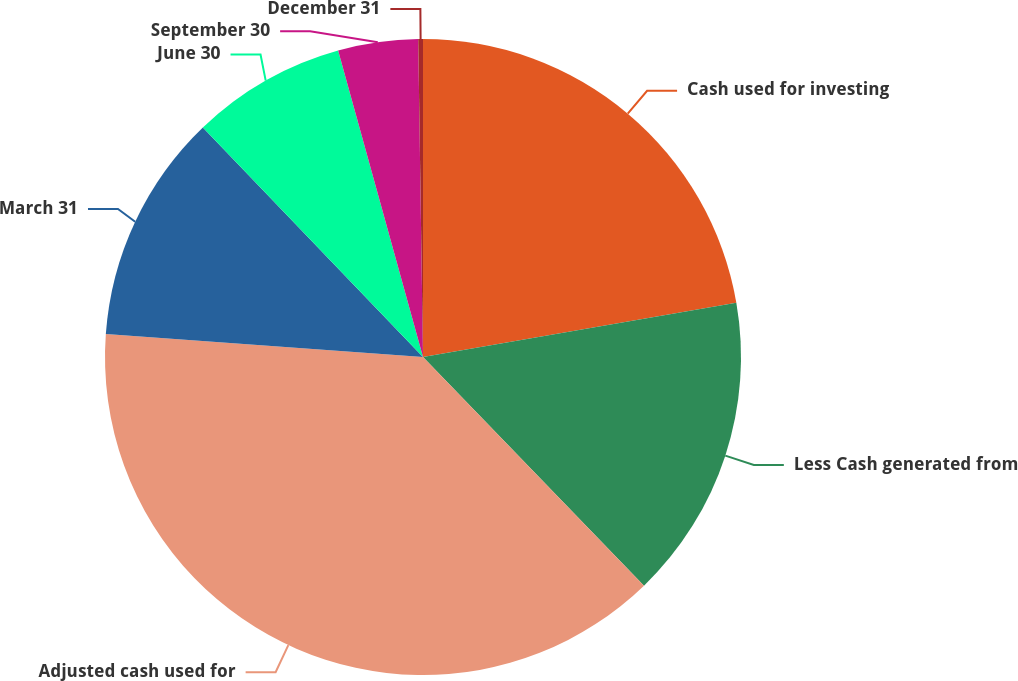Convert chart. <chart><loc_0><loc_0><loc_500><loc_500><pie_chart><fcel>Cash used for investing<fcel>Less Cash generated from<fcel>Adjusted cash used for<fcel>March 31<fcel>June 30<fcel>September 30<fcel>December 31<nl><fcel>22.27%<fcel>15.5%<fcel>38.38%<fcel>11.68%<fcel>7.87%<fcel>4.06%<fcel>0.24%<nl></chart> 